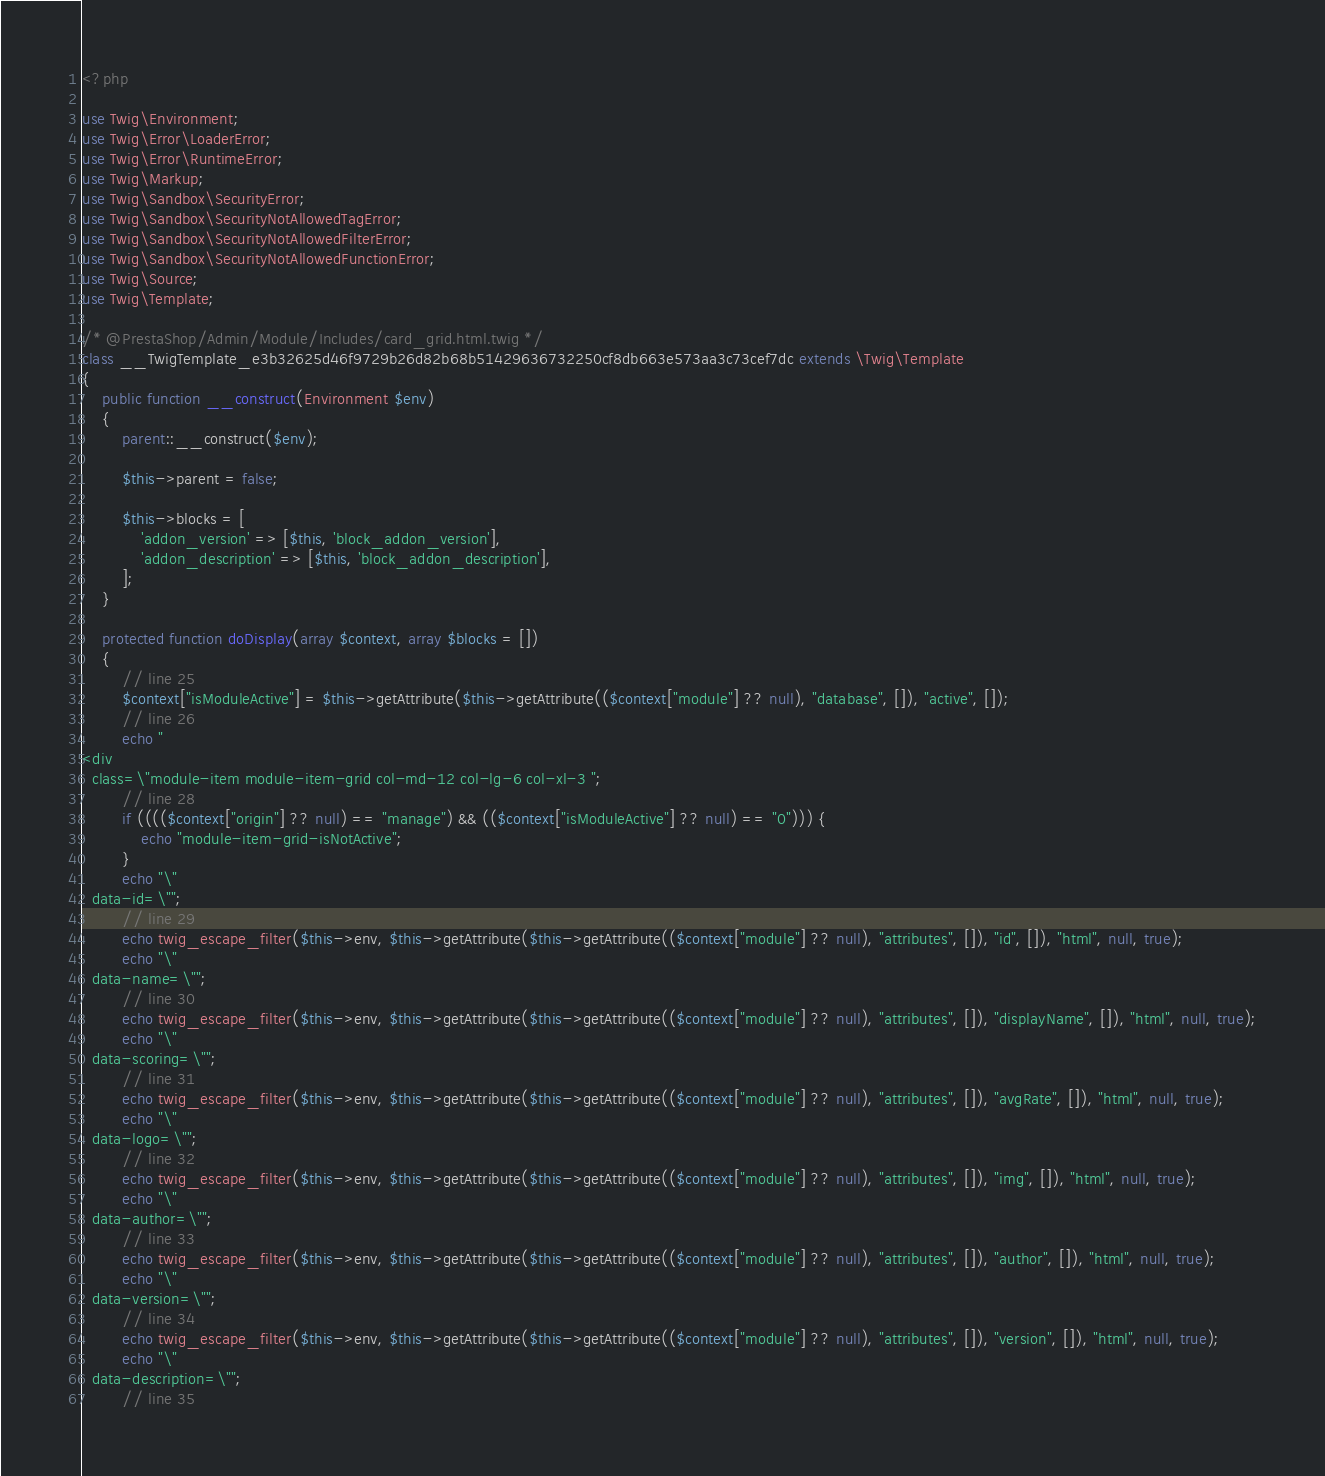Convert code to text. <code><loc_0><loc_0><loc_500><loc_500><_PHP_><?php

use Twig\Environment;
use Twig\Error\LoaderError;
use Twig\Error\RuntimeError;
use Twig\Markup;
use Twig\Sandbox\SecurityError;
use Twig\Sandbox\SecurityNotAllowedTagError;
use Twig\Sandbox\SecurityNotAllowedFilterError;
use Twig\Sandbox\SecurityNotAllowedFunctionError;
use Twig\Source;
use Twig\Template;

/* @PrestaShop/Admin/Module/Includes/card_grid.html.twig */
class __TwigTemplate_e3b32625d46f9729b26d82b68b51429636732250cf8db663e573aa3c73cef7dc extends \Twig\Template
{
    public function __construct(Environment $env)
    {
        parent::__construct($env);

        $this->parent = false;

        $this->blocks = [
            'addon_version' => [$this, 'block_addon_version'],
            'addon_description' => [$this, 'block_addon_description'],
        ];
    }

    protected function doDisplay(array $context, array $blocks = [])
    {
        // line 25
        $context["isModuleActive"] = $this->getAttribute($this->getAttribute(($context["module"] ?? null), "database", []), "active", []);
        // line 26
        echo "
<div
  class=\"module-item module-item-grid col-md-12 col-lg-6 col-xl-3 ";
        // line 28
        if (((($context["origin"] ?? null) == "manage") && (($context["isModuleActive"] ?? null) == "0"))) {
            echo "module-item-grid-isNotActive";
        }
        echo "\"
  data-id=\"";
        // line 29
        echo twig_escape_filter($this->env, $this->getAttribute($this->getAttribute(($context["module"] ?? null), "attributes", []), "id", []), "html", null, true);
        echo "\"
  data-name=\"";
        // line 30
        echo twig_escape_filter($this->env, $this->getAttribute($this->getAttribute(($context["module"] ?? null), "attributes", []), "displayName", []), "html", null, true);
        echo "\"
  data-scoring=\"";
        // line 31
        echo twig_escape_filter($this->env, $this->getAttribute($this->getAttribute(($context["module"] ?? null), "attributes", []), "avgRate", []), "html", null, true);
        echo "\"
  data-logo=\"";
        // line 32
        echo twig_escape_filter($this->env, $this->getAttribute($this->getAttribute(($context["module"] ?? null), "attributes", []), "img", []), "html", null, true);
        echo "\"
  data-author=\"";
        // line 33
        echo twig_escape_filter($this->env, $this->getAttribute($this->getAttribute(($context["module"] ?? null), "attributes", []), "author", []), "html", null, true);
        echo "\"
  data-version=\"";
        // line 34
        echo twig_escape_filter($this->env, $this->getAttribute($this->getAttribute(($context["module"] ?? null), "attributes", []), "version", []), "html", null, true);
        echo "\"
  data-description=\"";
        // line 35</code> 